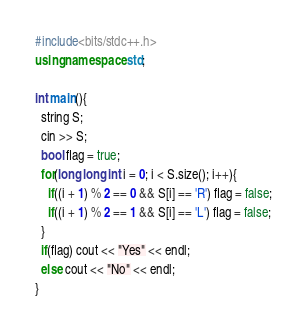Convert code to text. <code><loc_0><loc_0><loc_500><loc_500><_C++_>#include<bits/stdc++.h>
using namespace std;

int main(){
  string S;
  cin >> S;
  bool flag = true;
  for(long long int i = 0; i < S.size(); i++){
    if((i + 1) % 2 == 0 && S[i] == 'R') flag = false;
    if((i + 1) % 2 == 1 && S[i] == 'L') flag = false;
  }
  if(flag) cout << "Yes" << endl;
  else cout << "No" << endl;
}
</code> 